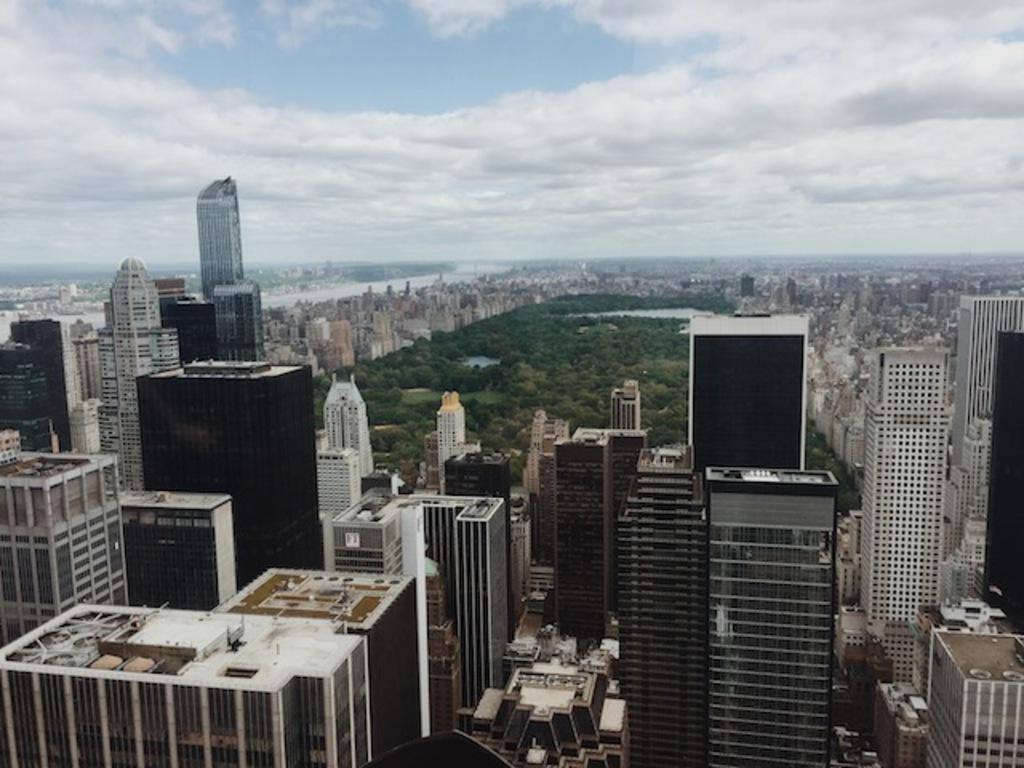What type of view is shown in the image? The image is an aerial view of a city. What are some notable features of the city? There are skyscrapers in the city, and there is a park in the middle of the city. What can be seen in the sky in the image? The sky is visible in the image, and clouds are present in the sky. What color is the toe of the person standing on the tallest skyscraper in the image? There are no people visible in the image, and therefore no toes can be seen. 